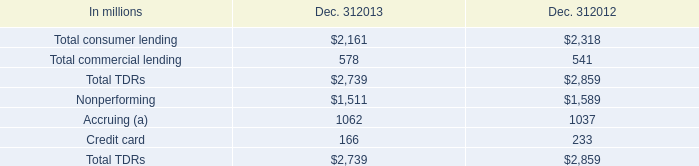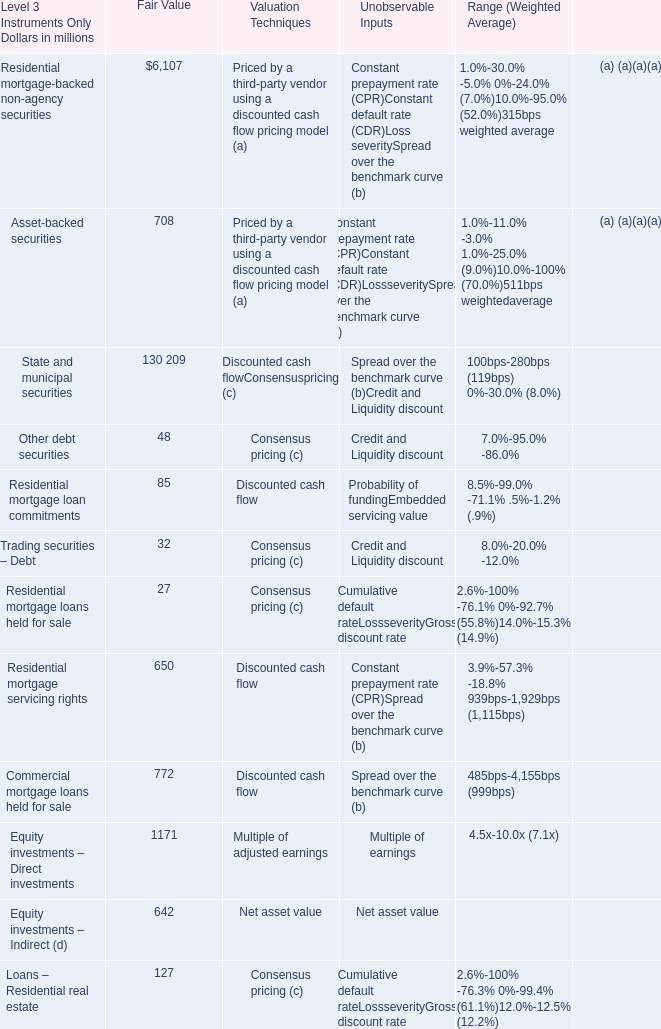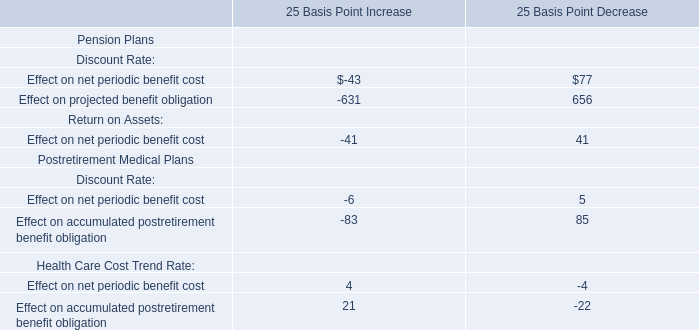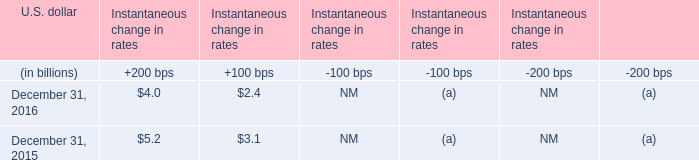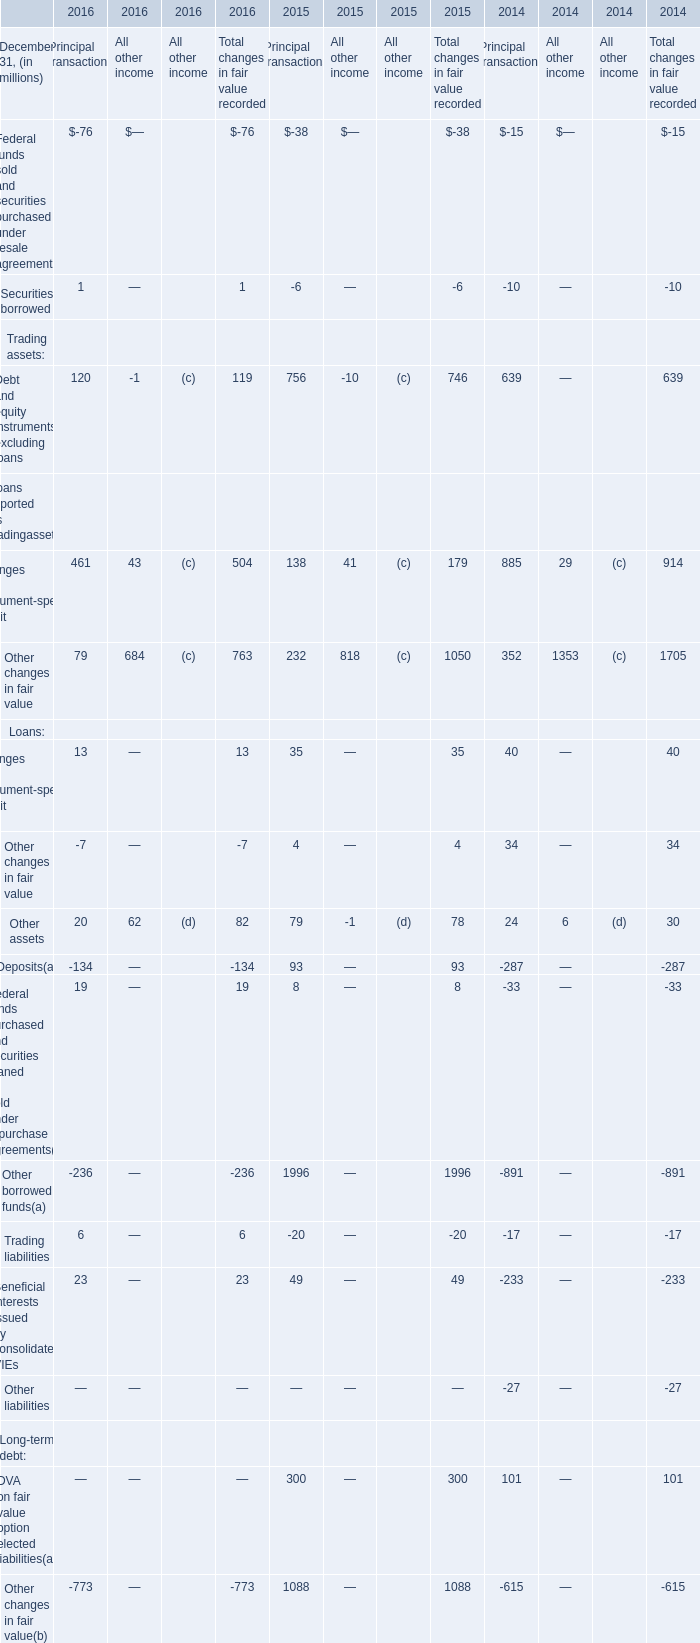How much is the Fair Value for Residential mortgage loan commitments for Level 3 Instruments Only as As the chart 1 shows? (in million) 
Answer: 85. 